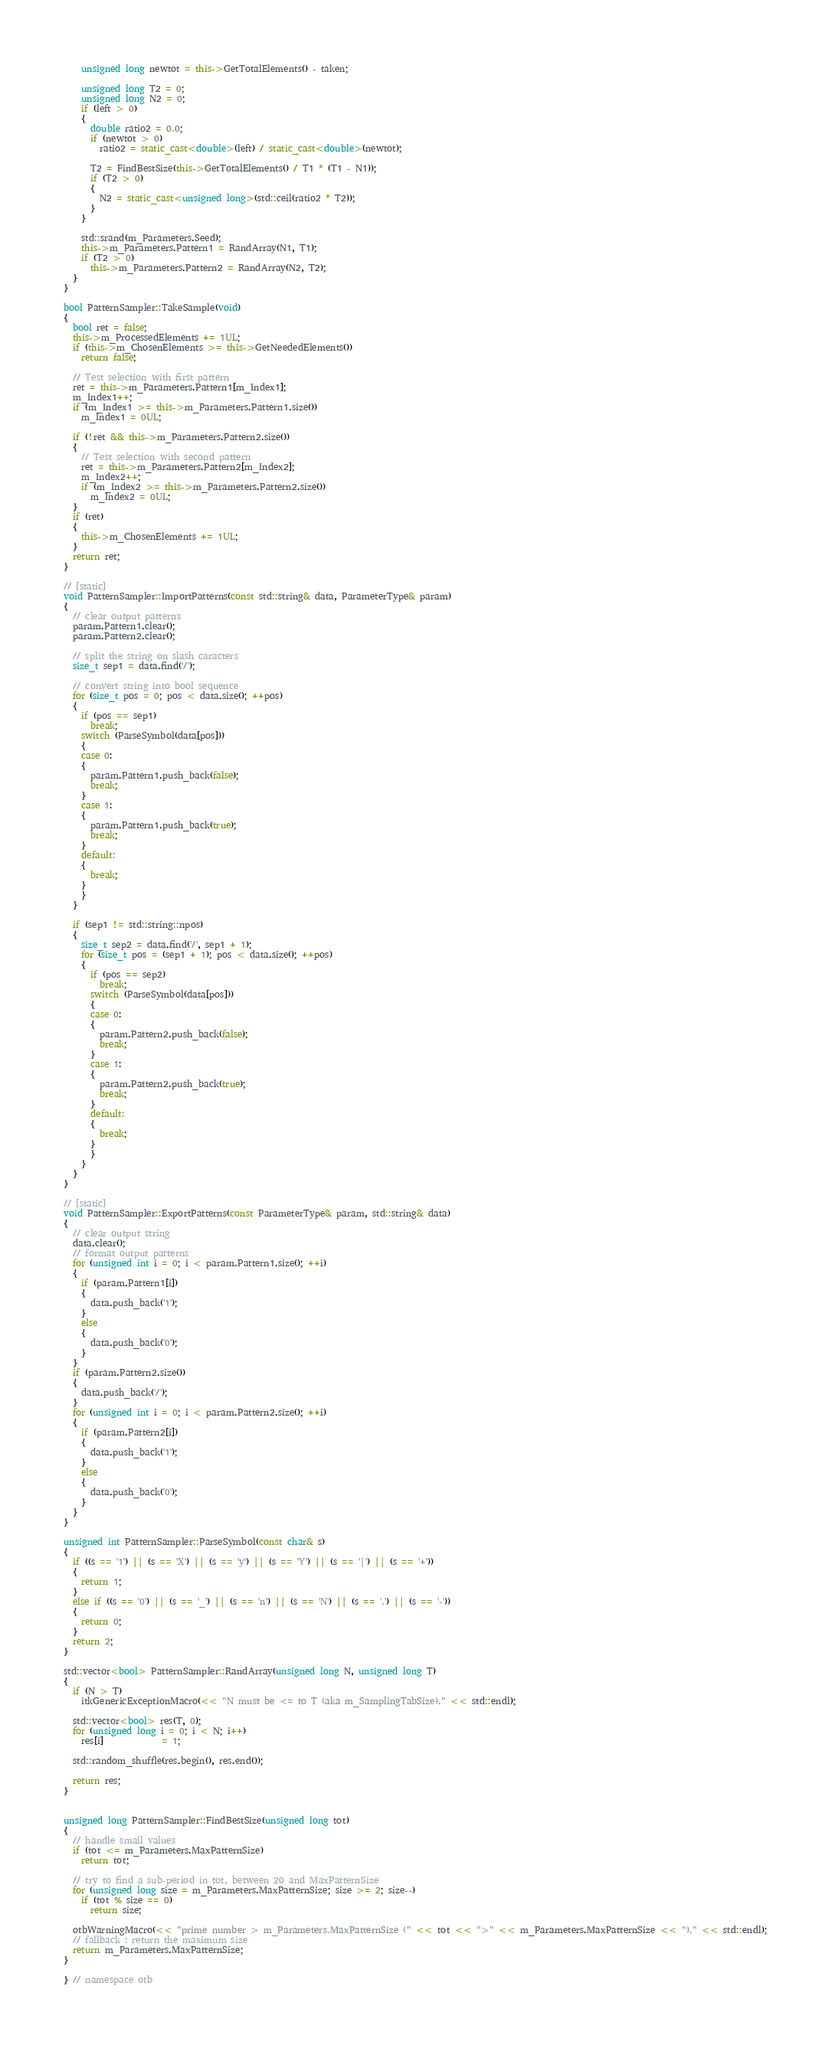<code> <loc_0><loc_0><loc_500><loc_500><_C++_>    unsigned long newtot = this->GetTotalElements() - taken;

    unsigned long T2 = 0;
    unsigned long N2 = 0;
    if (left > 0)
    {
      double ratio2 = 0.0;
      if (newtot > 0)
        ratio2 = static_cast<double>(left) / static_cast<double>(newtot);

      T2 = FindBestSize(this->GetTotalElements() / T1 * (T1 - N1));
      if (T2 > 0)
      {
        N2 = static_cast<unsigned long>(std::ceil(ratio2 * T2));
      }
    }

    std::srand(m_Parameters.Seed);
    this->m_Parameters.Pattern1 = RandArray(N1, T1);
    if (T2 > 0)
      this->m_Parameters.Pattern2 = RandArray(N2, T2);
  }
}

bool PatternSampler::TakeSample(void)
{
  bool ret = false;
  this->m_ProcessedElements += 1UL;
  if (this->m_ChosenElements >= this->GetNeededElements())
    return false;

  // Test selection with first pattern
  ret = this->m_Parameters.Pattern1[m_Index1];
  m_Index1++;
  if (m_Index1 >= this->m_Parameters.Pattern1.size())
    m_Index1 = 0UL;

  if (!ret && this->m_Parameters.Pattern2.size())
  {
    // Test selection with second pattern
    ret = this->m_Parameters.Pattern2[m_Index2];
    m_Index2++;
    if (m_Index2 >= this->m_Parameters.Pattern2.size())
      m_Index2 = 0UL;
  }
  if (ret)
  {
    this->m_ChosenElements += 1UL;
  }
  return ret;
}

// [static]
void PatternSampler::ImportPatterns(const std::string& data, ParameterType& param)
{
  // clear output patterns
  param.Pattern1.clear();
  param.Pattern2.clear();

  // split the string on slash caracters
  size_t sep1 = data.find('/');

  // convert string into bool sequence
  for (size_t pos = 0; pos < data.size(); ++pos)
  {
    if (pos == sep1)
      break;
    switch (ParseSymbol(data[pos]))
    {
    case 0:
    {
      param.Pattern1.push_back(false);
      break;
    }
    case 1:
    {
      param.Pattern1.push_back(true);
      break;
    }
    default:
    {
      break;
    }
    }
  }

  if (sep1 != std::string::npos)
  {
    size_t sep2 = data.find('/', sep1 + 1);
    for (size_t pos = (sep1 + 1); pos < data.size(); ++pos)
    {
      if (pos == sep2)
        break;
      switch (ParseSymbol(data[pos]))
      {
      case 0:
      {
        param.Pattern2.push_back(false);
        break;
      }
      case 1:
      {
        param.Pattern2.push_back(true);
        break;
      }
      default:
      {
        break;
      }
      }
    }
  }
}

// [static]
void PatternSampler::ExportPatterns(const ParameterType& param, std::string& data)
{
  // clear output string
  data.clear();
  // format output patterns
  for (unsigned int i = 0; i < param.Pattern1.size(); ++i)
  {
    if (param.Pattern1[i])
    {
      data.push_back('1');
    }
    else
    {
      data.push_back('0');
    }
  }
  if (param.Pattern2.size())
  {
    data.push_back('/');
  }
  for (unsigned int i = 0; i < param.Pattern2.size(); ++i)
  {
    if (param.Pattern2[i])
    {
      data.push_back('1');
    }
    else
    {
      data.push_back('0');
    }
  }
}

unsigned int PatternSampler::ParseSymbol(const char& s)
{
  if ((s == '1') || (s == 'X') || (s == 'y') || (s == 'Y') || (s == '|') || (s == '+'))
  {
    return 1;
  }
  else if ((s == '0') || (s == '_') || (s == 'n') || (s == 'N') || (s == '.') || (s == '-'))
  {
    return 0;
  }
  return 2;
}

std::vector<bool> PatternSampler::RandArray(unsigned long N, unsigned long T)
{
  if (N > T)
    itkGenericExceptionMacro(<< "N must be <= to T (aka m_SamplingTabSize)." << std::endl);

  std::vector<bool> res(T, 0);
  for (unsigned long i = 0; i < N; i++)
    res[i]             = 1;

  std::random_shuffle(res.begin(), res.end());

  return res;
}


unsigned long PatternSampler::FindBestSize(unsigned long tot)
{
  // handle small values
  if (tot <= m_Parameters.MaxPatternSize)
    return tot;

  // try to find a sub-period in tot, between 20 and MaxPatternSize
  for (unsigned long size = m_Parameters.MaxPatternSize; size >= 2; size--)
    if (tot % size == 0)
      return size;

  otbWarningMacro(<< "prime number > m_Parameters.MaxPatternSize (" << tot << ">" << m_Parameters.MaxPatternSize << ")." << std::endl);
  // fallback : return the maximum size
  return m_Parameters.MaxPatternSize;
}

} // namespace otb
</code> 